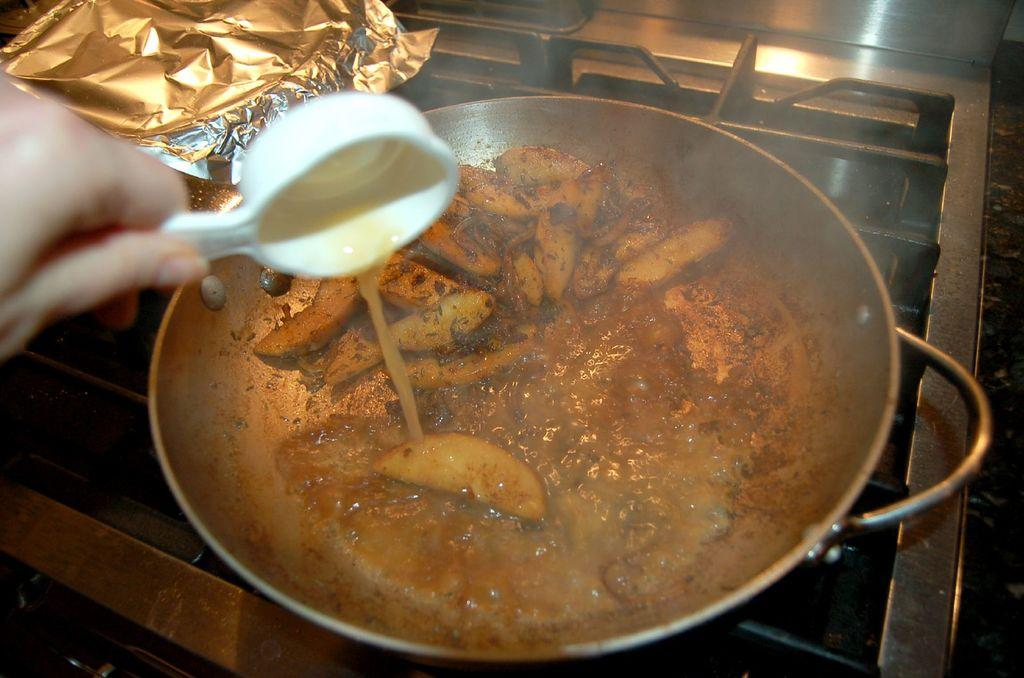What is on the stove in the image? There is a bowl on the stove in the image. What is inside the bowl? There is a food item in the bowl. Can you describe the person's hand in the image? A person's hand is holding a spoon in the image. How many cattle can be seen grazing in the background of the image? There are no cattle visible in the image; it only shows a bowl on the stove and a person's hand holding a spoon. What type of print is on the person's shirt in the image? There is no information about the person's shirt or any print on it in the image. 